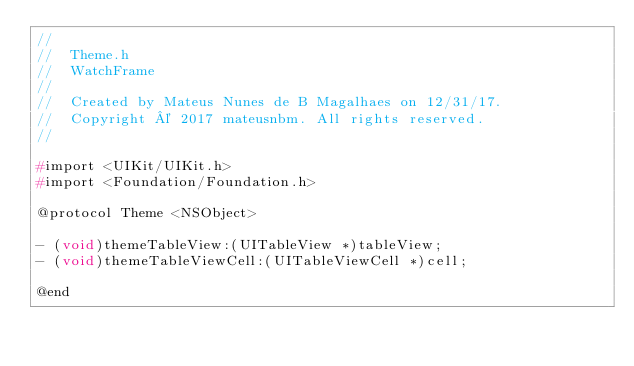<code> <loc_0><loc_0><loc_500><loc_500><_C_>//
//  Theme.h
//  WatchFrame
//
//  Created by Mateus Nunes de B Magalhaes on 12/31/17.
//  Copyright © 2017 mateusnbm. All rights reserved.
//

#import <UIKit/UIKit.h>
#import <Foundation/Foundation.h>

@protocol Theme <NSObject>

- (void)themeTableView:(UITableView *)tableView;
- (void)themeTableViewCell:(UITableViewCell *)cell;

@end
</code> 